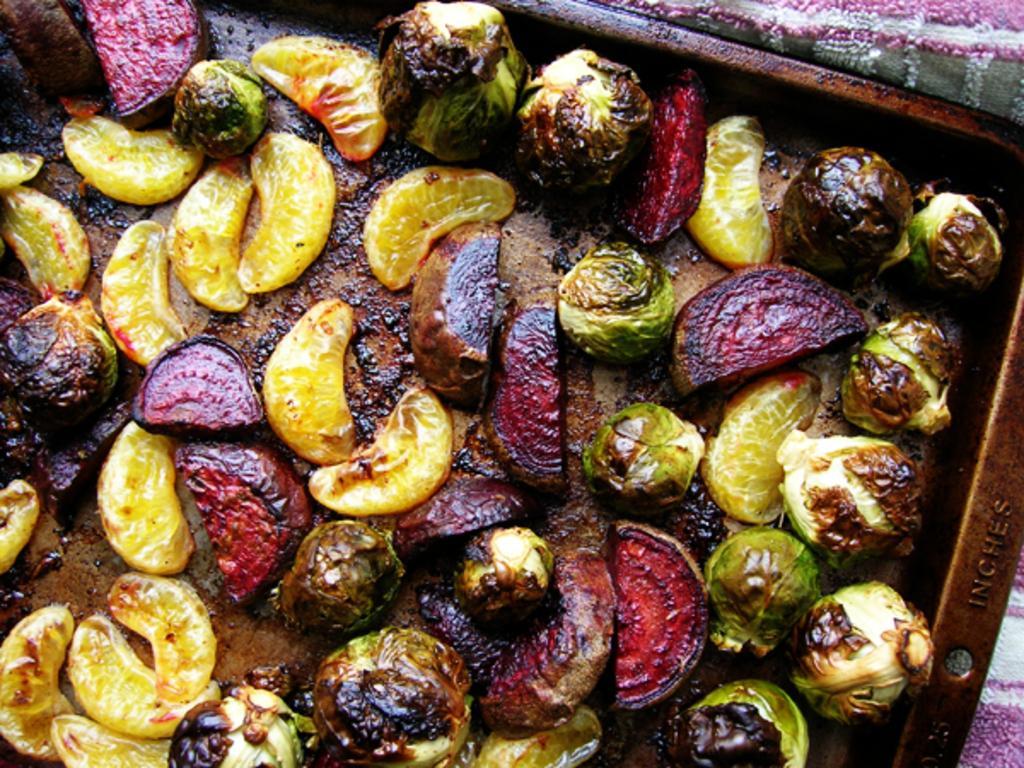Describe this image in one or two sentences. In the foreground of this image, there are vegetables and fruits on a tray and a cloth in the background. 